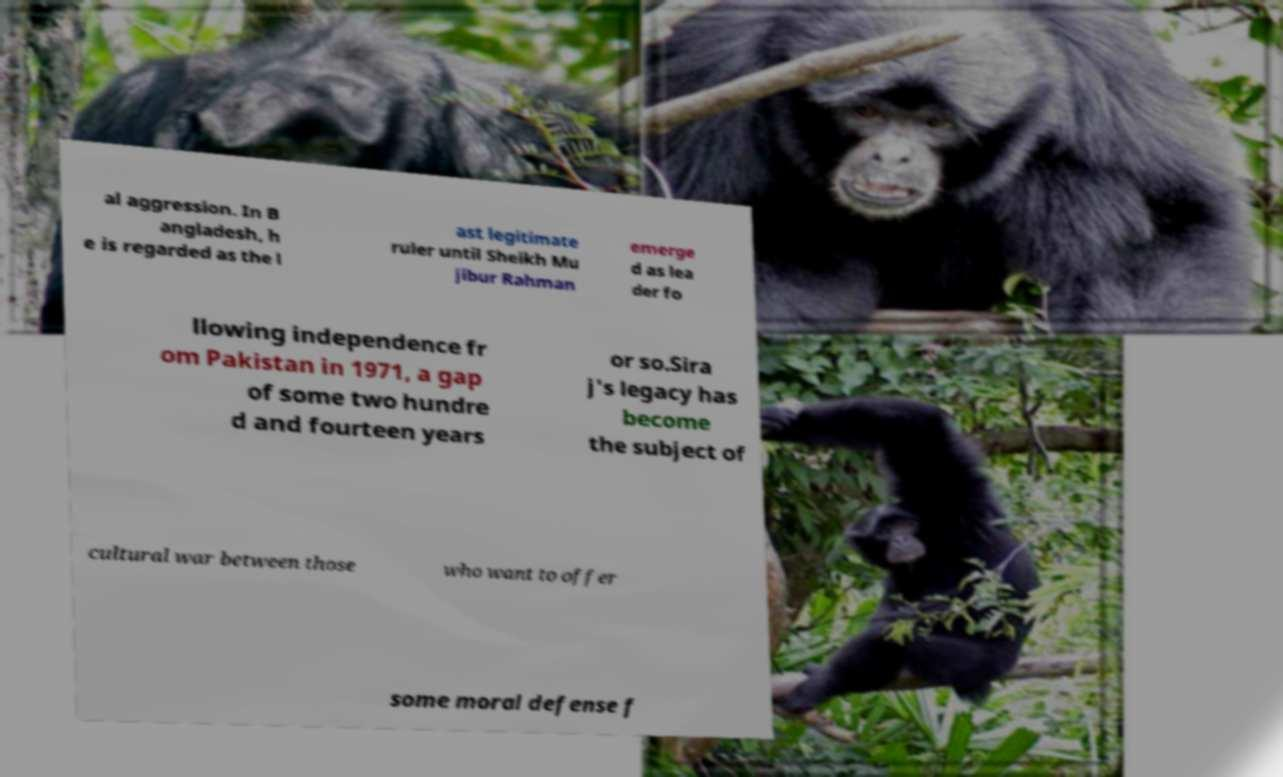Please identify and transcribe the text found in this image. al aggression. In B angladesh, h e is regarded as the l ast legitimate ruler until Sheikh Mu jibur Rahman emerge d as lea der fo llowing independence fr om Pakistan in 1971, a gap of some two hundre d and fourteen years or so.Sira j's legacy has become the subject of cultural war between those who want to offer some moral defense f 